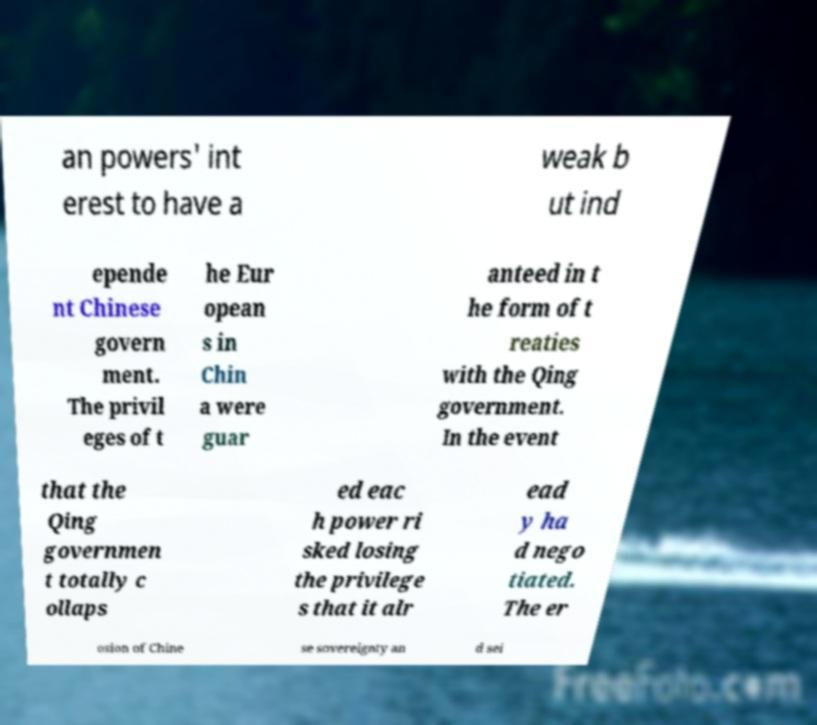For documentation purposes, I need the text within this image transcribed. Could you provide that? an powers' int erest to have a weak b ut ind epende nt Chinese govern ment. The privil eges of t he Eur opean s in Chin a were guar anteed in t he form of t reaties with the Qing government. In the event that the Qing governmen t totally c ollaps ed eac h power ri sked losing the privilege s that it alr ead y ha d nego tiated. The er osion of Chine se sovereignty an d sei 